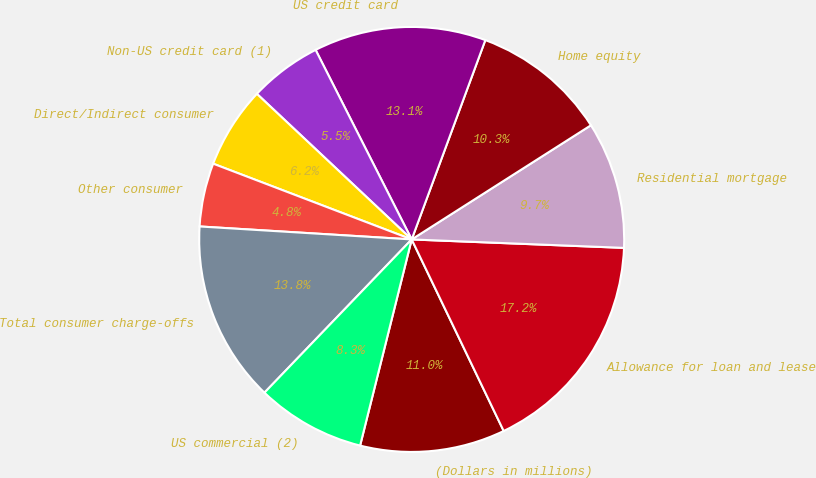Convert chart. <chart><loc_0><loc_0><loc_500><loc_500><pie_chart><fcel>(Dollars in millions)<fcel>Allowance for loan and lease<fcel>Residential mortgage<fcel>Home equity<fcel>US credit card<fcel>Non-US credit card (1)<fcel>Direct/Indirect consumer<fcel>Other consumer<fcel>Total consumer charge-offs<fcel>US commercial (2)<nl><fcel>11.03%<fcel>17.24%<fcel>9.66%<fcel>10.34%<fcel>13.1%<fcel>5.52%<fcel>6.21%<fcel>4.83%<fcel>13.79%<fcel>8.28%<nl></chart> 